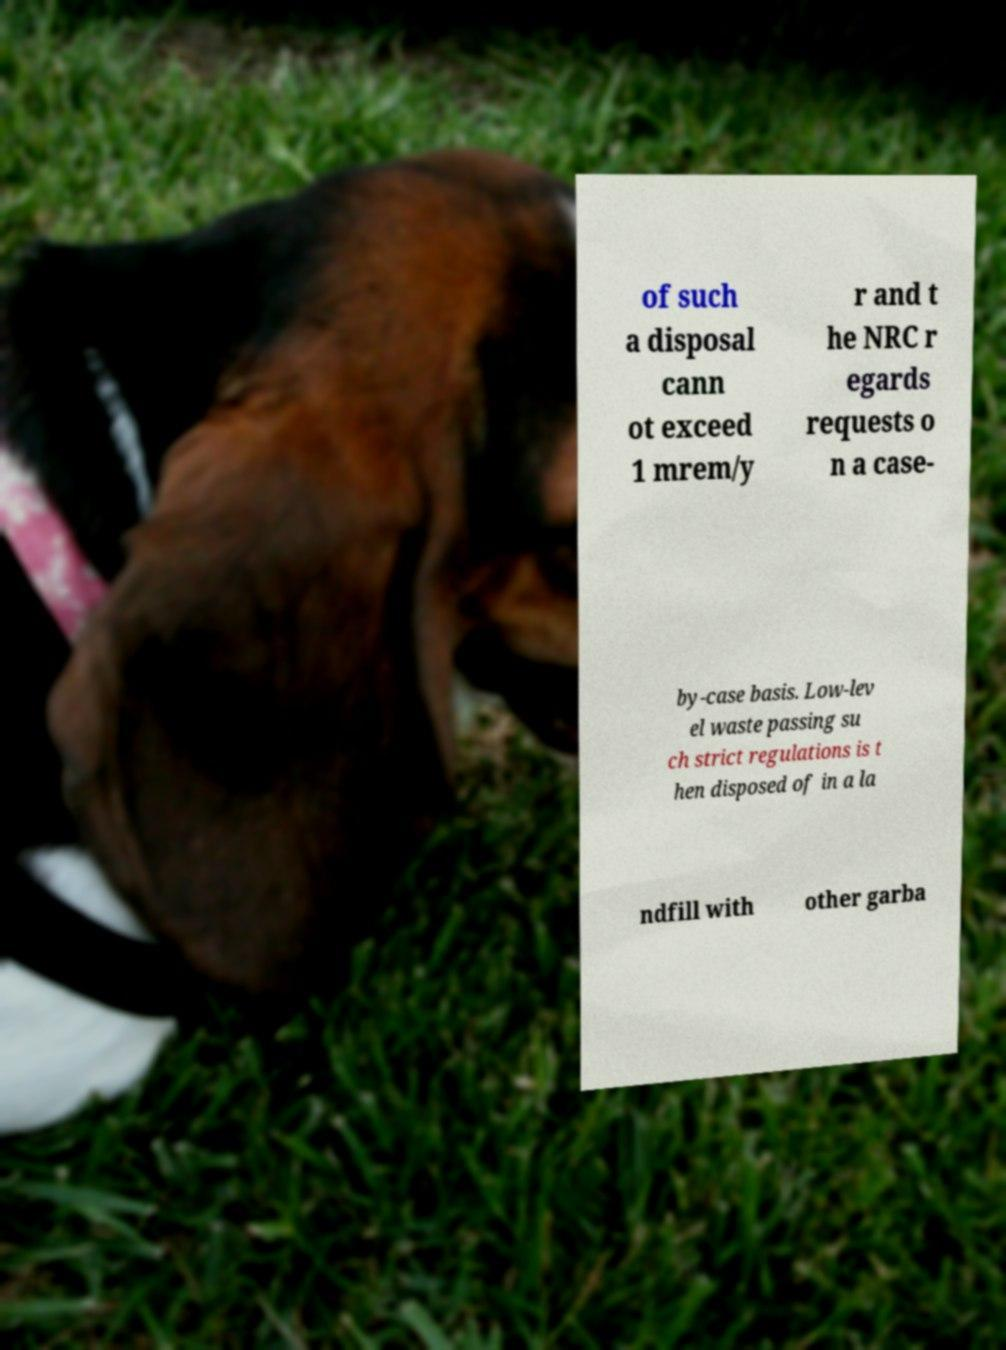There's text embedded in this image that I need extracted. Can you transcribe it verbatim? of such a disposal cann ot exceed 1 mrem/y r and t he NRC r egards requests o n a case- by-case basis. Low-lev el waste passing su ch strict regulations is t hen disposed of in a la ndfill with other garba 